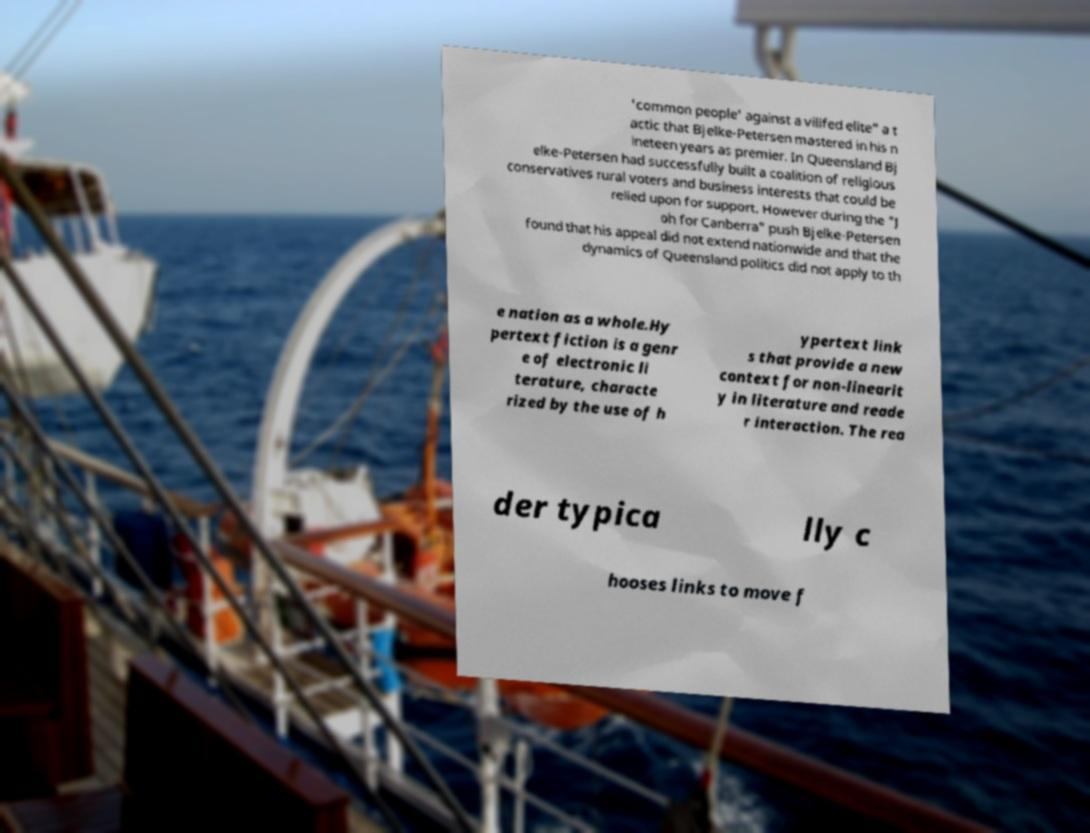Can you read and provide the text displayed in the image?This photo seems to have some interesting text. Can you extract and type it out for me? 'common people' against a vilifed elite" a t actic that Bjelke-Petersen mastered in his n ineteen years as premier. In Queensland Bj elke-Petersen had successfully built a coalition of religious conservatives rural voters and business interests that could be relied upon for support. However during the "J oh for Canberra" push Bjelke-Petersen found that his appeal did not extend nationwide and that the dynamics of Queensland politics did not apply to th e nation as a whole.Hy pertext fiction is a genr e of electronic li terature, characte rized by the use of h ypertext link s that provide a new context for non-linearit y in literature and reade r interaction. The rea der typica lly c hooses links to move f 